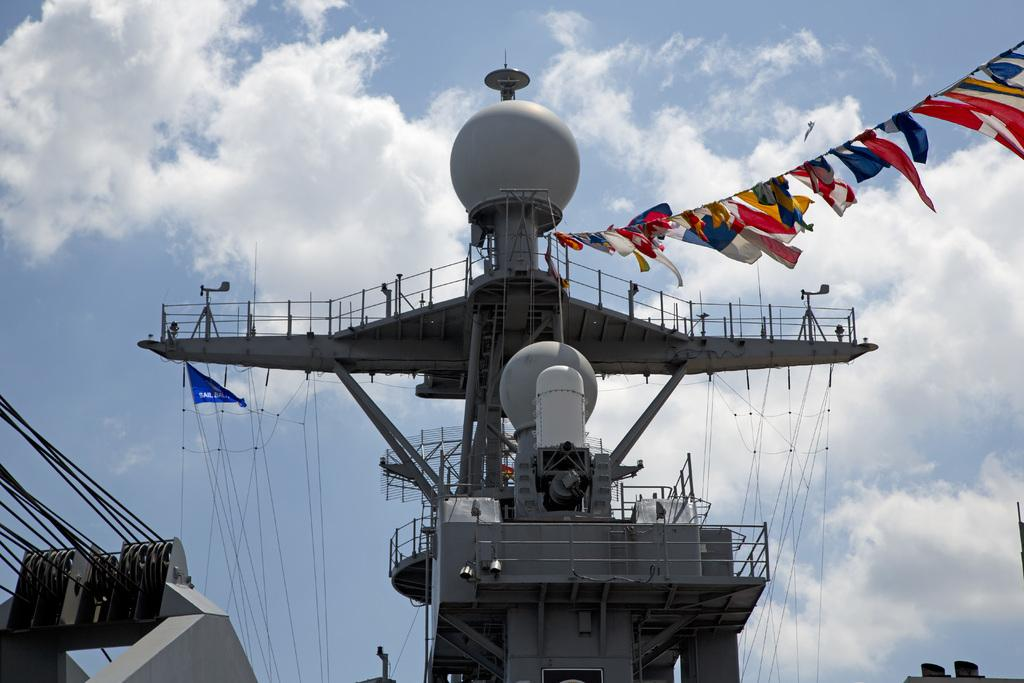What type of structures can be seen in the image? There are railings, rods, and ropes in the image. What is attached to the rods in the image? Flags are attached to the rods in the image. What is the condition of the sky in the background of the image? The background of the image includes a cloudy sky. What type of dinner is being served in the image? There is no dinner present in the image; it features railings, rods, ropes, and flags. Is there a camp visible in the image? There is no camp present in the image; it features railings, rods, ropes, and flags. 